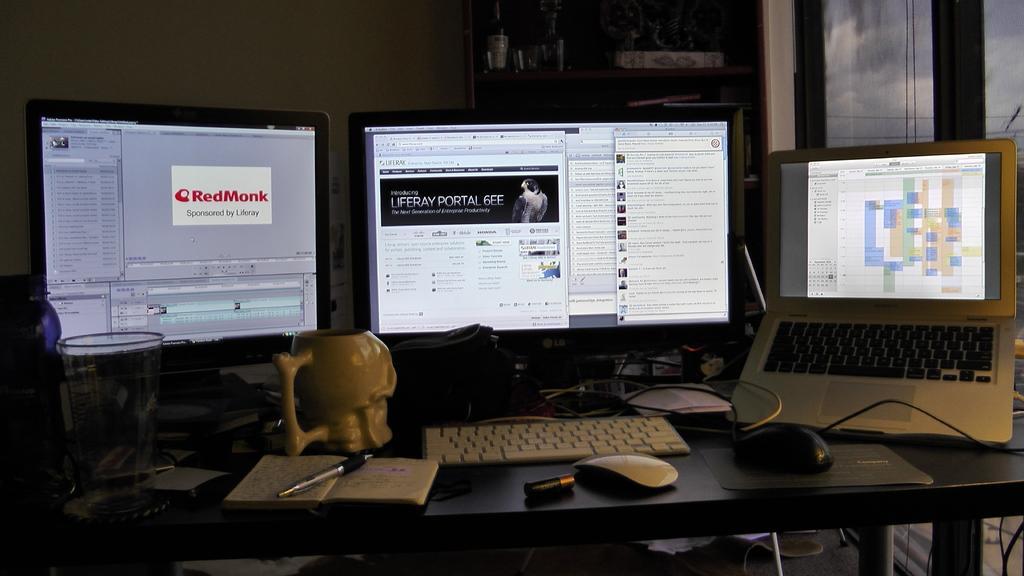How would you summarize this image in a sentence or two? In this picture we can see a laptop, few monitors, keyboard, book, pen, mice, glass and other things on the table, in the background we can see few things in the racks. 